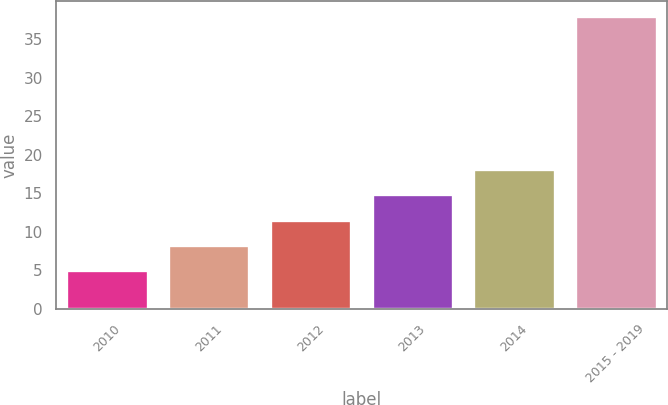Convert chart. <chart><loc_0><loc_0><loc_500><loc_500><bar_chart><fcel>2010<fcel>2011<fcel>2012<fcel>2013<fcel>2014<fcel>2015 - 2019<nl><fcel>5<fcel>8.3<fcel>11.6<fcel>14.9<fcel>18.2<fcel>38<nl></chart> 